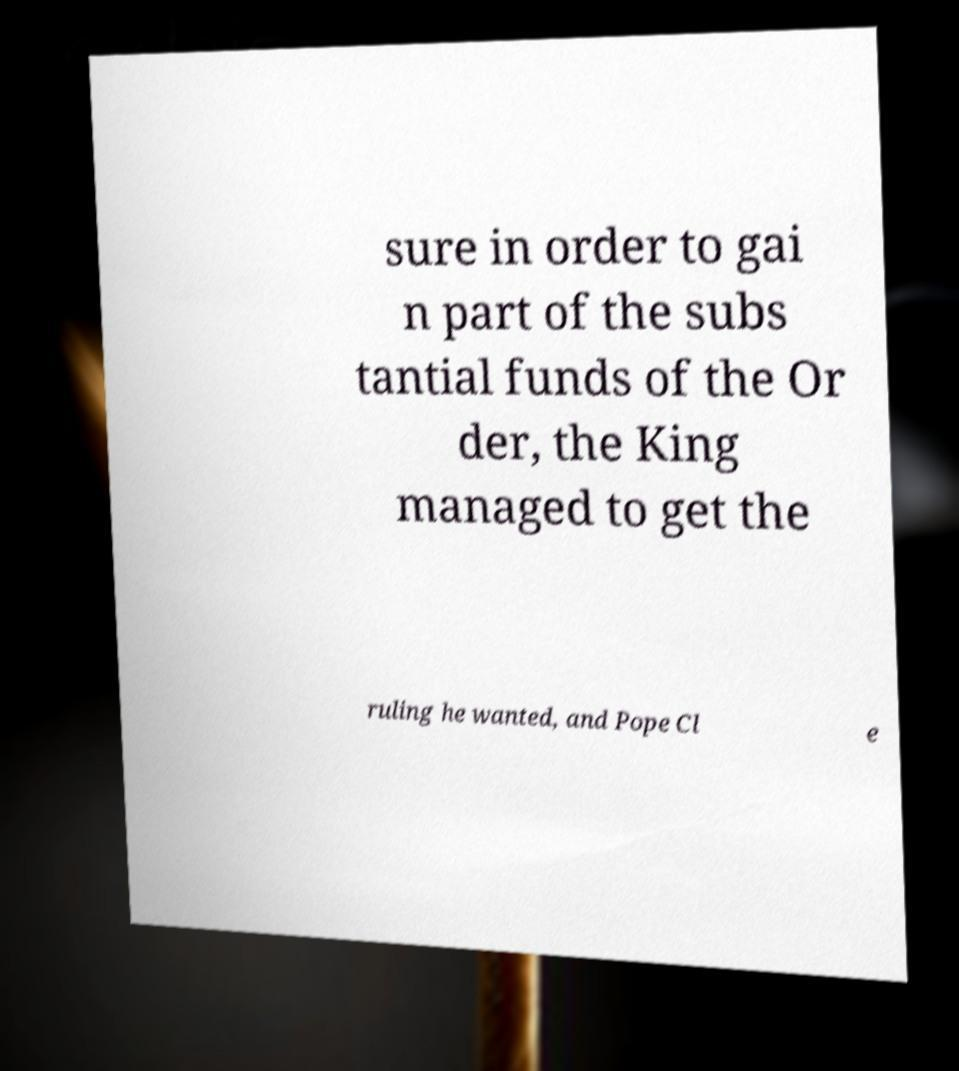What messages or text are displayed in this image? I need them in a readable, typed format. sure in order to gai n part of the subs tantial funds of the Or der, the King managed to get the ruling he wanted, and Pope Cl e 